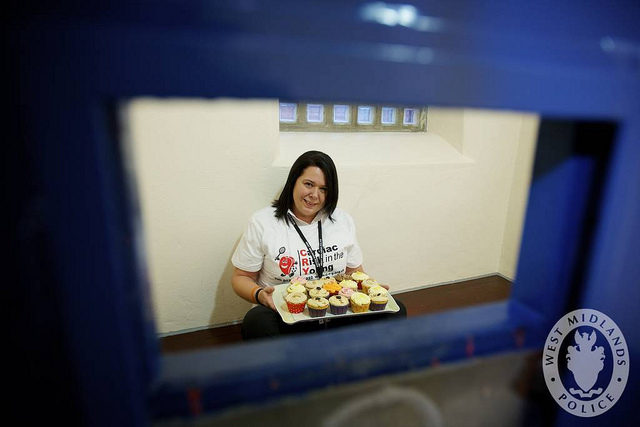Identify and read out the text in this image. CAREAC Ri Young POLICE MIDLANDS WEST the in 